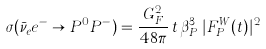Convert formula to latex. <formula><loc_0><loc_0><loc_500><loc_500>\sigma ( \bar { \nu } _ { e } e ^ { - } \to P ^ { 0 } P ^ { - } ) = \frac { G _ { F } ^ { 2 } } { 4 8 \pi } \, t \, \beta _ { P } ^ { 3 } \, | F _ { P } ^ { W } ( t ) | ^ { 2 }</formula> 